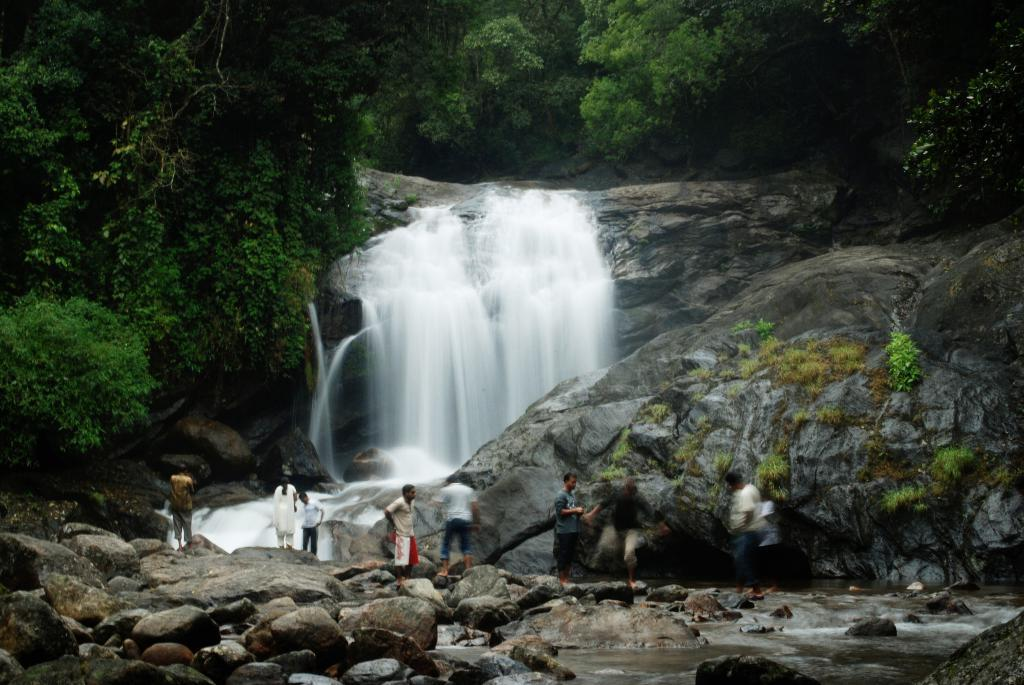What are the people in the image doing? The people in the image are standing on rocks. What can be seen in the background of the image? There is a waterfall and trees visible in the background of the image. How many books are being carried by the people in the image? There are no books visible in the image; the people are standing on rocks near a waterfall and trees. 